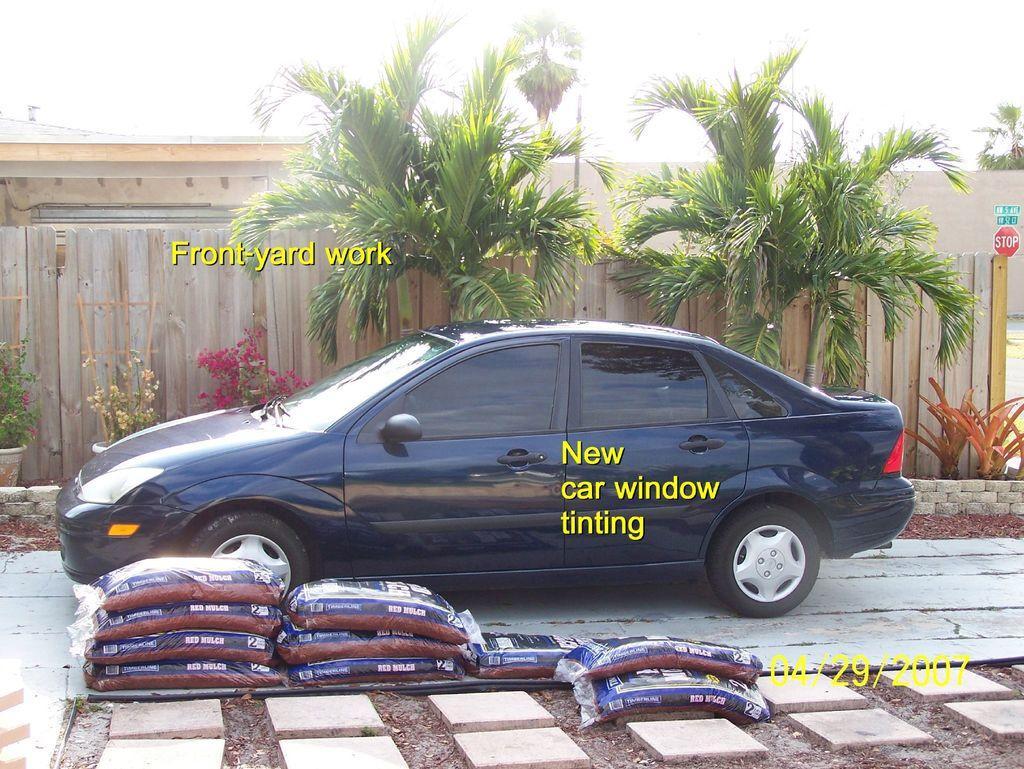In one or two sentences, can you explain what this image depicts? In this picture we can see a vehicle, bags and stones on the ground and in the background we can see plants, wooden sticks, wall, trees, here we can see some text. 